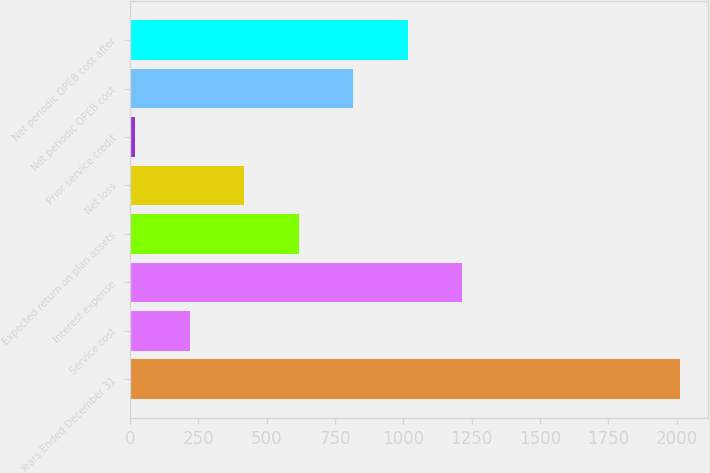Convert chart. <chart><loc_0><loc_0><loc_500><loc_500><bar_chart><fcel>Years Ended December 31<fcel>Service cost<fcel>Interest expense<fcel>Expected return on plan assets<fcel>Net loss<fcel>Prior service credit<fcel>Net periodic OPEB cost<fcel>Net periodic OPEB cost after<nl><fcel>2012<fcel>219.2<fcel>1215.2<fcel>617.6<fcel>418.4<fcel>20<fcel>816.8<fcel>1016<nl></chart> 